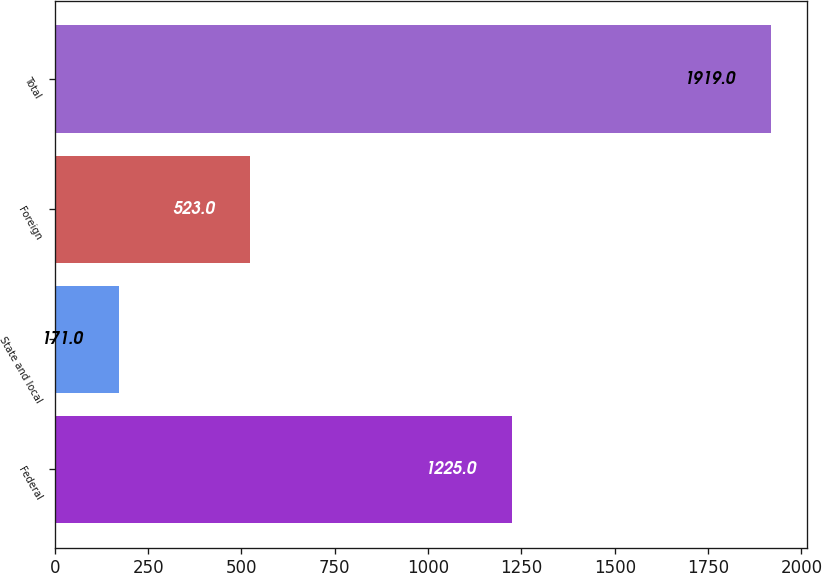Convert chart to OTSL. <chart><loc_0><loc_0><loc_500><loc_500><bar_chart><fcel>Federal<fcel>State and local<fcel>Foreign<fcel>Total<nl><fcel>1225<fcel>171<fcel>523<fcel>1919<nl></chart> 